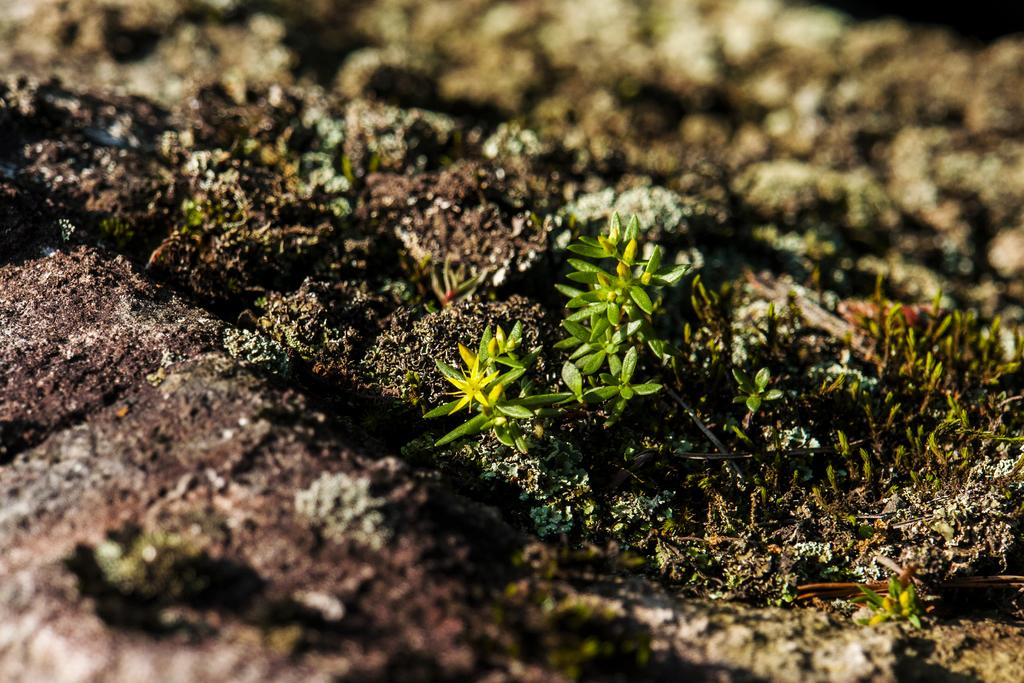Where was the image taken? The image is taken outdoors. What can be seen at the bottom of the image? There is a ground visible at the bottom of the image. Are there any plants in the image? Yes, there are a few little plants on the ground in the middle of the image. What type of potato is being used for arithmetic in the image? There is no potato or arithmetic activity present in the image. 